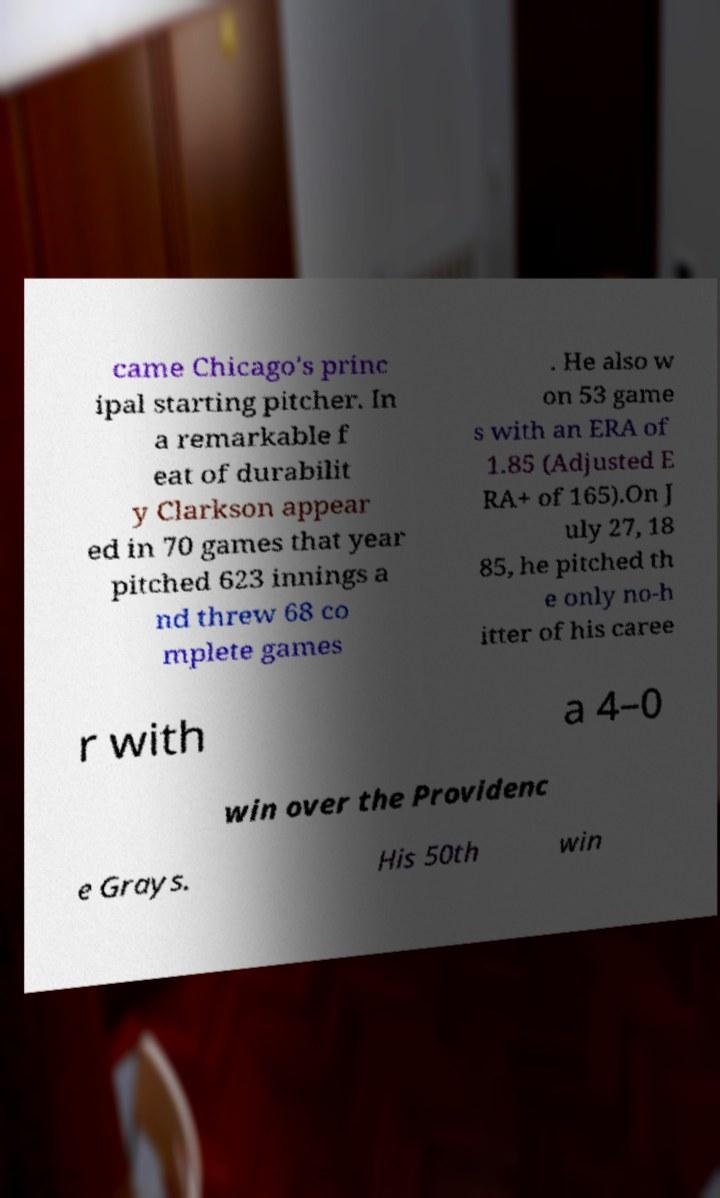Please identify and transcribe the text found in this image. came Chicago's princ ipal starting pitcher. In a remarkable f eat of durabilit y Clarkson appear ed in 70 games that year pitched 623 innings a nd threw 68 co mplete games . He also w on 53 game s with an ERA of 1.85 (Adjusted E RA+ of 165).On J uly 27, 18 85, he pitched th e only no-h itter of his caree r with a 4–0 win over the Providenc e Grays. His 50th win 